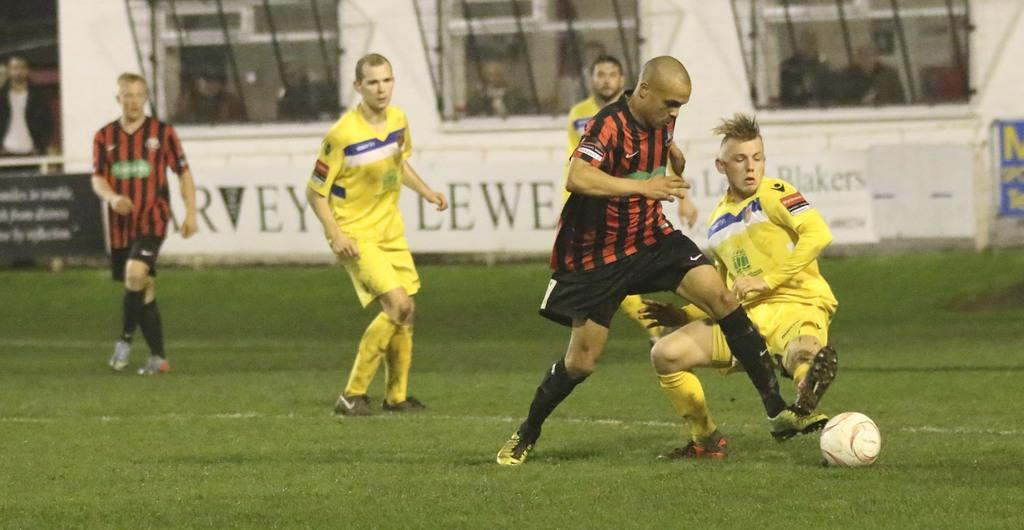<image>
Share a concise interpretation of the image provided. soccer players on a field with the letters LEWE on the wall behind them 